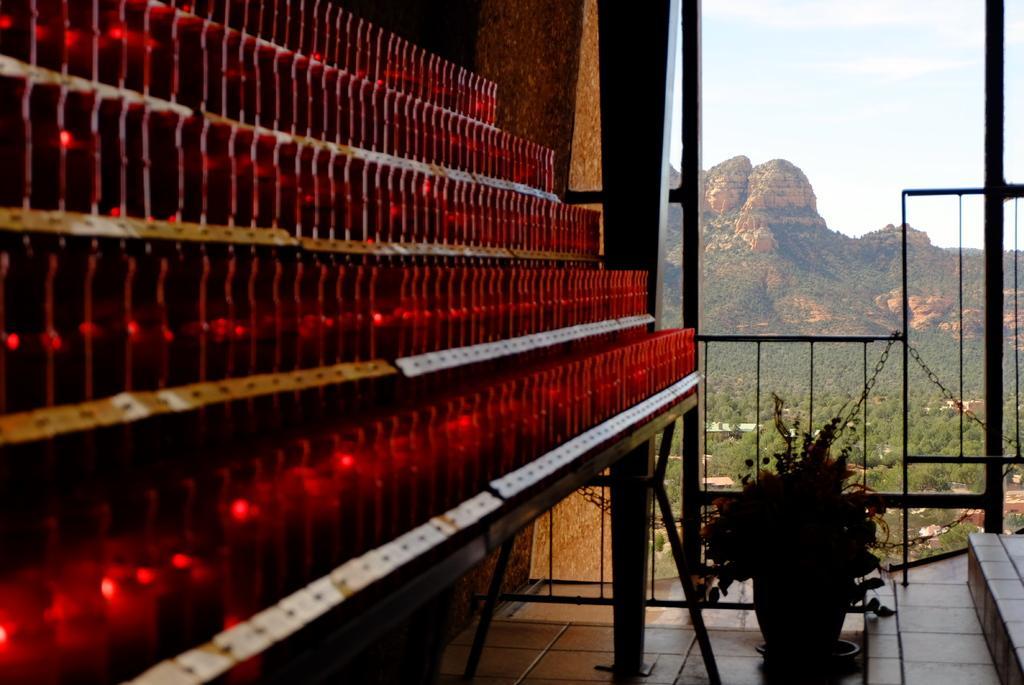How would you summarize this image in a sentence or two? In this picture there are few objects which are in red color are placed in rows and there is a plant pot beside it and there is a fence in front of it and there is a mountain and trees in the background. 